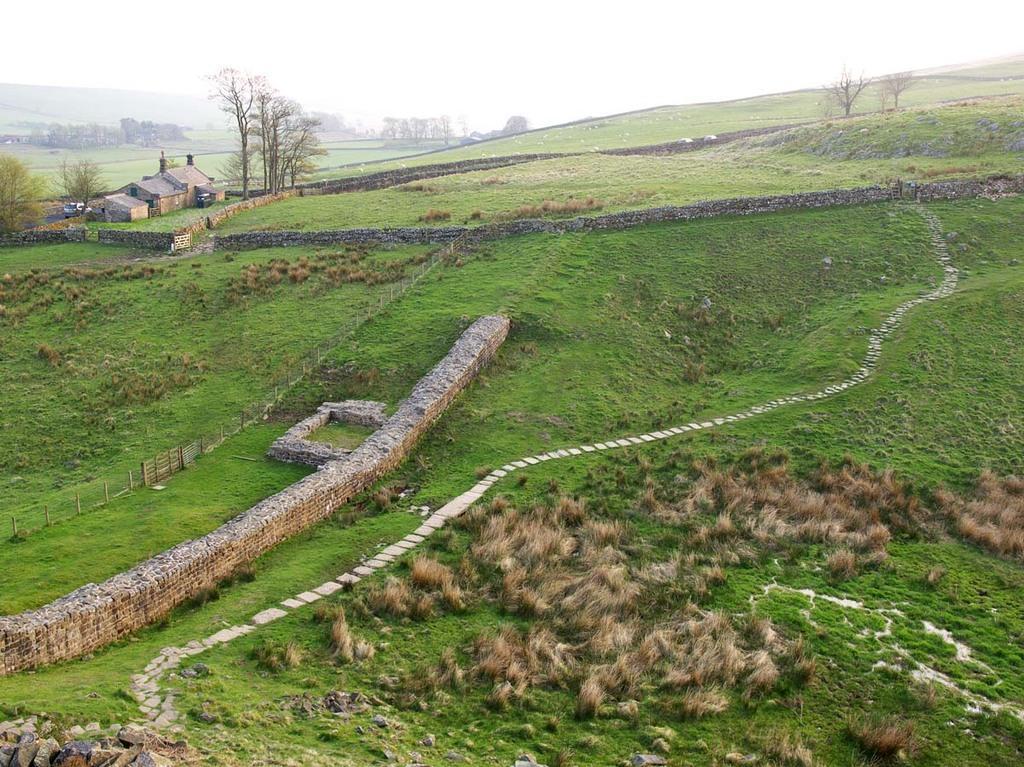Could you give a brief overview of what you see in this image? In this image, we can see some plants. There are walls in the middle of the image. There are some trees and shelter houses in the top left of the image. There is a sky at the top of the image. 